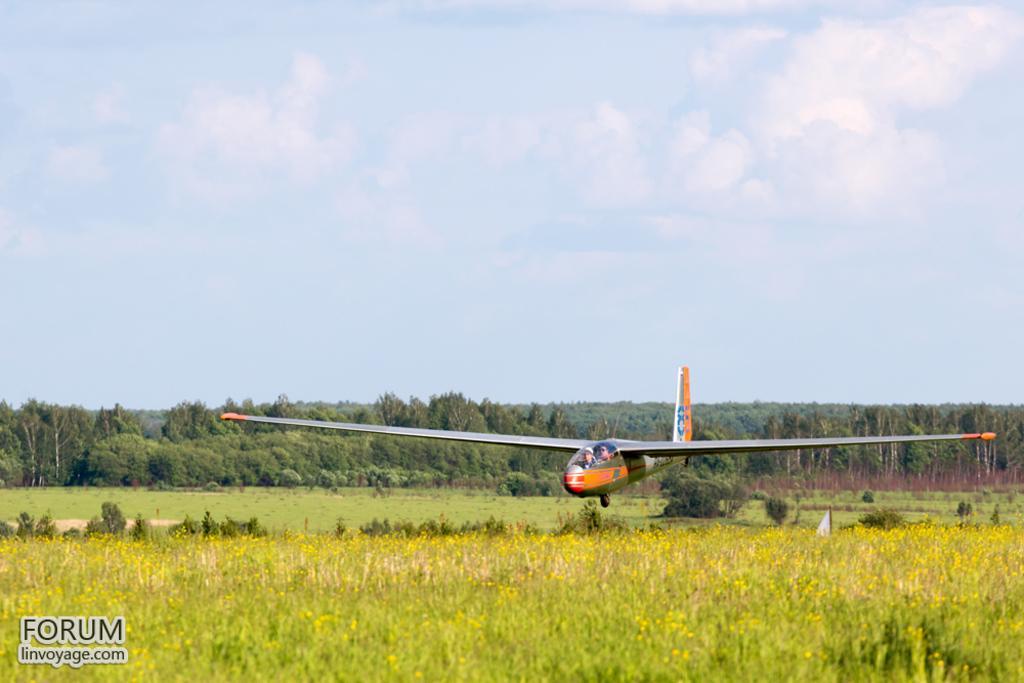How would you summarize this image in a sentence or two? In front of the image there are plants and flowers. There are two people in the plane and the plane is in the air. In the background of the image there are trees. At the bottom of the image there is grass on the surface. At the top of the image there are clouds in the sky. There is some text at the bottom of the image. 